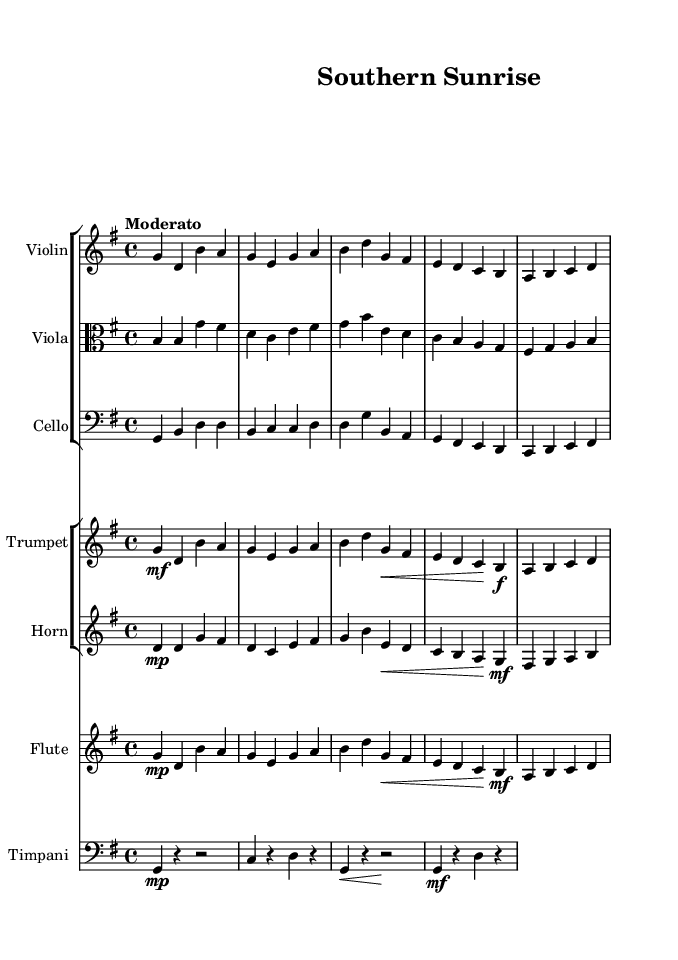What is the key signature of this music? The key signature is G major, which has one sharp (F#). This can be identified from the fact that the music is set in G major and indicated at the beginning of the score.
Answer: G major What is the time signature of this music? The time signature is 4/4, which means there are four beats in each measure and the quarter note gets one beat. This is shown at the beginning of the score.
Answer: 4/4 What is the tempo marking of this music? The tempo marking is "Moderato," indicating that the piece should be played at a moderate speed. This is indicated at the beginning of the score under the tempo section.
Answer: Moderato How many distinct instruments are present in this symphony? There are six distinct instruments featured in this symphony: Violin, Viola, Cello, Trumpet, Horn, Flute, and Timpani. This can be determined by counting the number of unique staves in the score.
Answer: Six Which instrument plays in the alto clef? The Viola plays in the alto clef, which is shown by the clef symbol placed at the beginning of the viola part. This clef is typically used for instruments such as the viola and is placed on the second line of the staff.
Answer: Viola How does the trumpet dynamic change in the second measure? In the second measure, the trumpet starts with a mezzo-forte (mf) dynamic, indicating it should be played moderately loud. This is noted by the mf marking before the first note of the second measure.
Answer: Mezzo-forte What is the significance of the timpani rests throughout the score? The timpani rests are used to create a sense of space and anticipation in the music. Specifically, in measures where there are rests, the absence of sound highlights the dynamics and rhythms of the other instruments. This technique is often utilized in symphonic music to enhance the overall emotional impact.
Answer: Creates space and anticipation 